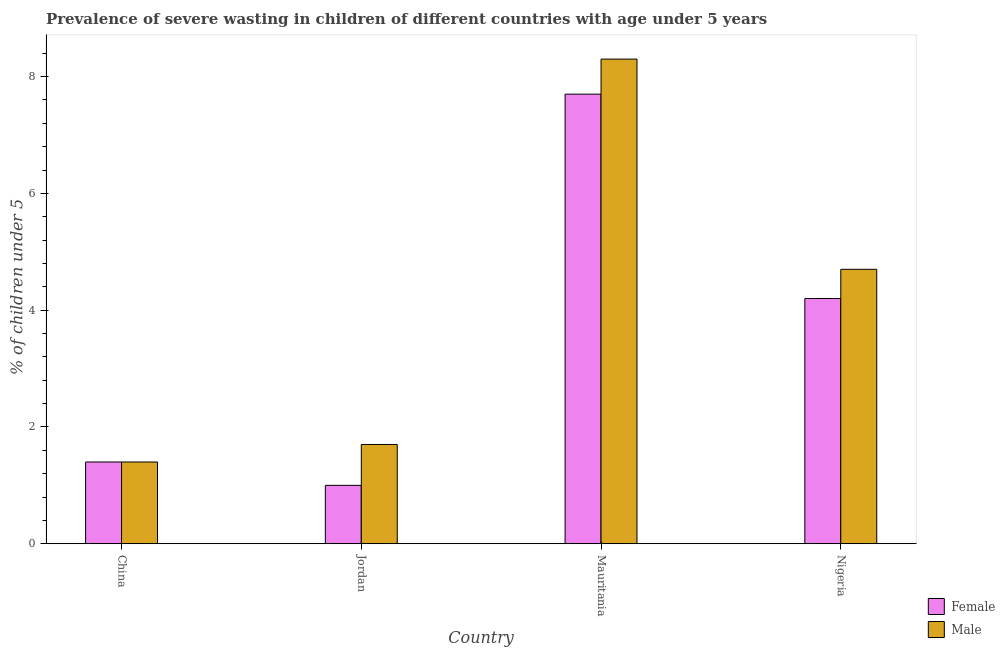How many different coloured bars are there?
Offer a terse response. 2. How many groups of bars are there?
Offer a terse response. 4. How many bars are there on the 3rd tick from the left?
Your answer should be very brief. 2. How many bars are there on the 4th tick from the right?
Your answer should be very brief. 2. What is the label of the 1st group of bars from the left?
Your answer should be very brief. China. What is the percentage of undernourished male children in Mauritania?
Your answer should be very brief. 8.3. Across all countries, what is the maximum percentage of undernourished female children?
Make the answer very short. 7.7. Across all countries, what is the minimum percentage of undernourished male children?
Ensure brevity in your answer.  1.4. In which country was the percentage of undernourished male children maximum?
Your answer should be very brief. Mauritania. In which country was the percentage of undernourished female children minimum?
Provide a short and direct response. Jordan. What is the total percentage of undernourished female children in the graph?
Provide a short and direct response. 14.3. What is the difference between the percentage of undernourished male children in Jordan and that in Nigeria?
Offer a very short reply. -3. What is the difference between the percentage of undernourished male children in China and the percentage of undernourished female children in Jordan?
Make the answer very short. 0.4. What is the average percentage of undernourished male children per country?
Your response must be concise. 4.03. What is the difference between the percentage of undernourished male children and percentage of undernourished female children in China?
Offer a very short reply. 0. What is the ratio of the percentage of undernourished male children in Mauritania to that in Nigeria?
Your response must be concise. 1.77. Is the percentage of undernourished male children in Mauritania less than that in Nigeria?
Offer a very short reply. No. What is the difference between the highest and the second highest percentage of undernourished female children?
Your response must be concise. 3.5. What is the difference between the highest and the lowest percentage of undernourished female children?
Your answer should be very brief. 6.7. Is the sum of the percentage of undernourished male children in Mauritania and Nigeria greater than the maximum percentage of undernourished female children across all countries?
Keep it short and to the point. Yes. What does the 1st bar from the left in Nigeria represents?
Keep it short and to the point. Female. Where does the legend appear in the graph?
Keep it short and to the point. Bottom right. What is the title of the graph?
Ensure brevity in your answer.  Prevalence of severe wasting in children of different countries with age under 5 years. What is the label or title of the X-axis?
Ensure brevity in your answer.  Country. What is the label or title of the Y-axis?
Your response must be concise.  % of children under 5. What is the  % of children under 5 of Female in China?
Your answer should be very brief. 1.4. What is the  % of children under 5 of Male in China?
Your answer should be very brief. 1.4. What is the  % of children under 5 in Male in Jordan?
Your answer should be very brief. 1.7. What is the  % of children under 5 in Female in Mauritania?
Ensure brevity in your answer.  7.7. What is the  % of children under 5 of Male in Mauritania?
Provide a succinct answer. 8.3. What is the  % of children under 5 of Female in Nigeria?
Ensure brevity in your answer.  4.2. What is the  % of children under 5 of Male in Nigeria?
Your answer should be very brief. 4.7. Across all countries, what is the maximum  % of children under 5 in Female?
Provide a succinct answer. 7.7. Across all countries, what is the maximum  % of children under 5 in Male?
Give a very brief answer. 8.3. Across all countries, what is the minimum  % of children under 5 of Female?
Make the answer very short. 1. Across all countries, what is the minimum  % of children under 5 of Male?
Give a very brief answer. 1.4. What is the total  % of children under 5 of Female in the graph?
Offer a very short reply. 14.3. What is the difference between the  % of children under 5 in Male in China and that in Jordan?
Give a very brief answer. -0.3. What is the difference between the  % of children under 5 of Female in China and that in Nigeria?
Give a very brief answer. -2.8. What is the difference between the  % of children under 5 in Male in Jordan and that in Mauritania?
Offer a terse response. -6.6. What is the difference between the  % of children under 5 in Female in Jordan and that in Nigeria?
Ensure brevity in your answer.  -3.2. What is the difference between the  % of children under 5 of Female in China and the  % of children under 5 of Male in Nigeria?
Offer a very short reply. -3.3. What is the difference between the  % of children under 5 in Female in Jordan and the  % of children under 5 in Male in Mauritania?
Offer a terse response. -7.3. What is the difference between the  % of children under 5 of Female in Mauritania and the  % of children under 5 of Male in Nigeria?
Ensure brevity in your answer.  3. What is the average  % of children under 5 of Female per country?
Your answer should be compact. 3.58. What is the average  % of children under 5 of Male per country?
Offer a terse response. 4.03. What is the difference between the  % of children under 5 in Female and  % of children under 5 in Male in China?
Your response must be concise. 0. What is the ratio of the  % of children under 5 of Female in China to that in Jordan?
Your response must be concise. 1.4. What is the ratio of the  % of children under 5 in Male in China to that in Jordan?
Your answer should be compact. 0.82. What is the ratio of the  % of children under 5 of Female in China to that in Mauritania?
Give a very brief answer. 0.18. What is the ratio of the  % of children under 5 of Male in China to that in Mauritania?
Keep it short and to the point. 0.17. What is the ratio of the  % of children under 5 in Male in China to that in Nigeria?
Provide a short and direct response. 0.3. What is the ratio of the  % of children under 5 in Female in Jordan to that in Mauritania?
Your answer should be very brief. 0.13. What is the ratio of the  % of children under 5 in Male in Jordan to that in Mauritania?
Your answer should be very brief. 0.2. What is the ratio of the  % of children under 5 in Female in Jordan to that in Nigeria?
Your answer should be compact. 0.24. What is the ratio of the  % of children under 5 of Male in Jordan to that in Nigeria?
Offer a very short reply. 0.36. What is the ratio of the  % of children under 5 of Female in Mauritania to that in Nigeria?
Your response must be concise. 1.83. What is the ratio of the  % of children under 5 of Male in Mauritania to that in Nigeria?
Provide a succinct answer. 1.77. 